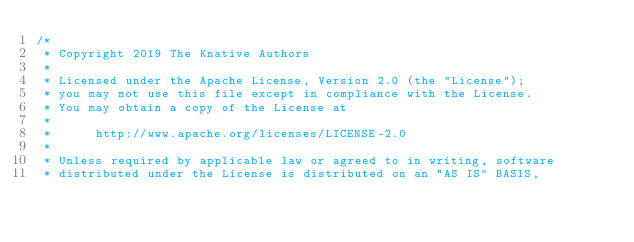<code> <loc_0><loc_0><loc_500><loc_500><_Go_>/*
 * Copyright 2019 The Knative Authors
 *
 * Licensed under the Apache License, Version 2.0 (the "License");
 * you may not use this file except in compliance with the License.
 * You may obtain a copy of the License at
 *
 *      http://www.apache.org/licenses/LICENSE-2.0
 *
 * Unless required by applicable law or agreed to in writing, software
 * distributed under the License is distributed on an "AS IS" BASIS,</code> 